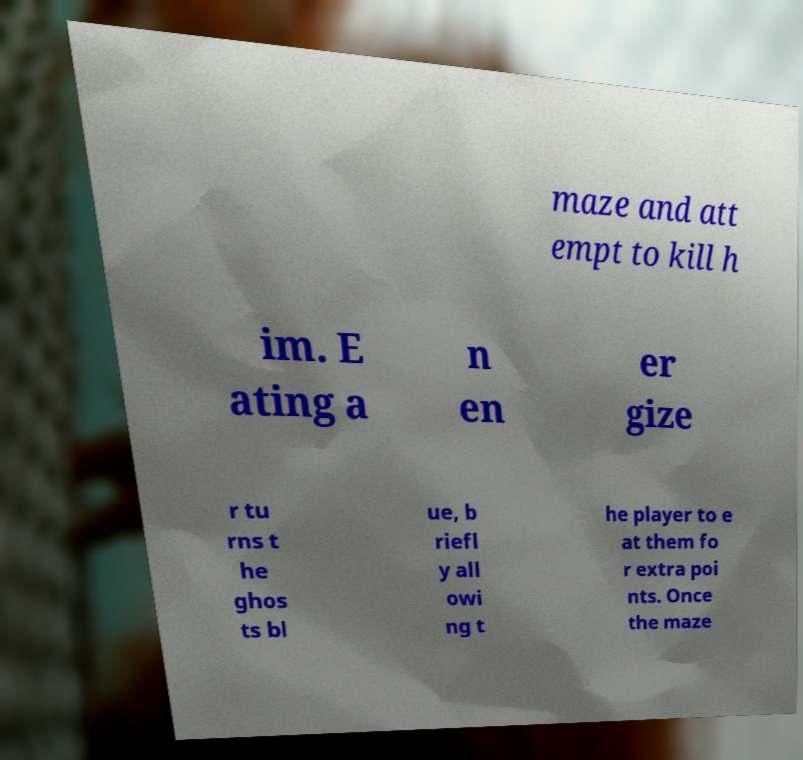What messages or text are displayed in this image? I need them in a readable, typed format. maze and att empt to kill h im. E ating a n en er gize r tu rns t he ghos ts bl ue, b riefl y all owi ng t he player to e at them fo r extra poi nts. Once the maze 